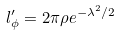<formula> <loc_0><loc_0><loc_500><loc_500>l ^ { \prime } _ { \phi } = 2 \pi \rho e ^ { - \lambda ^ { 2 } / 2 }</formula> 